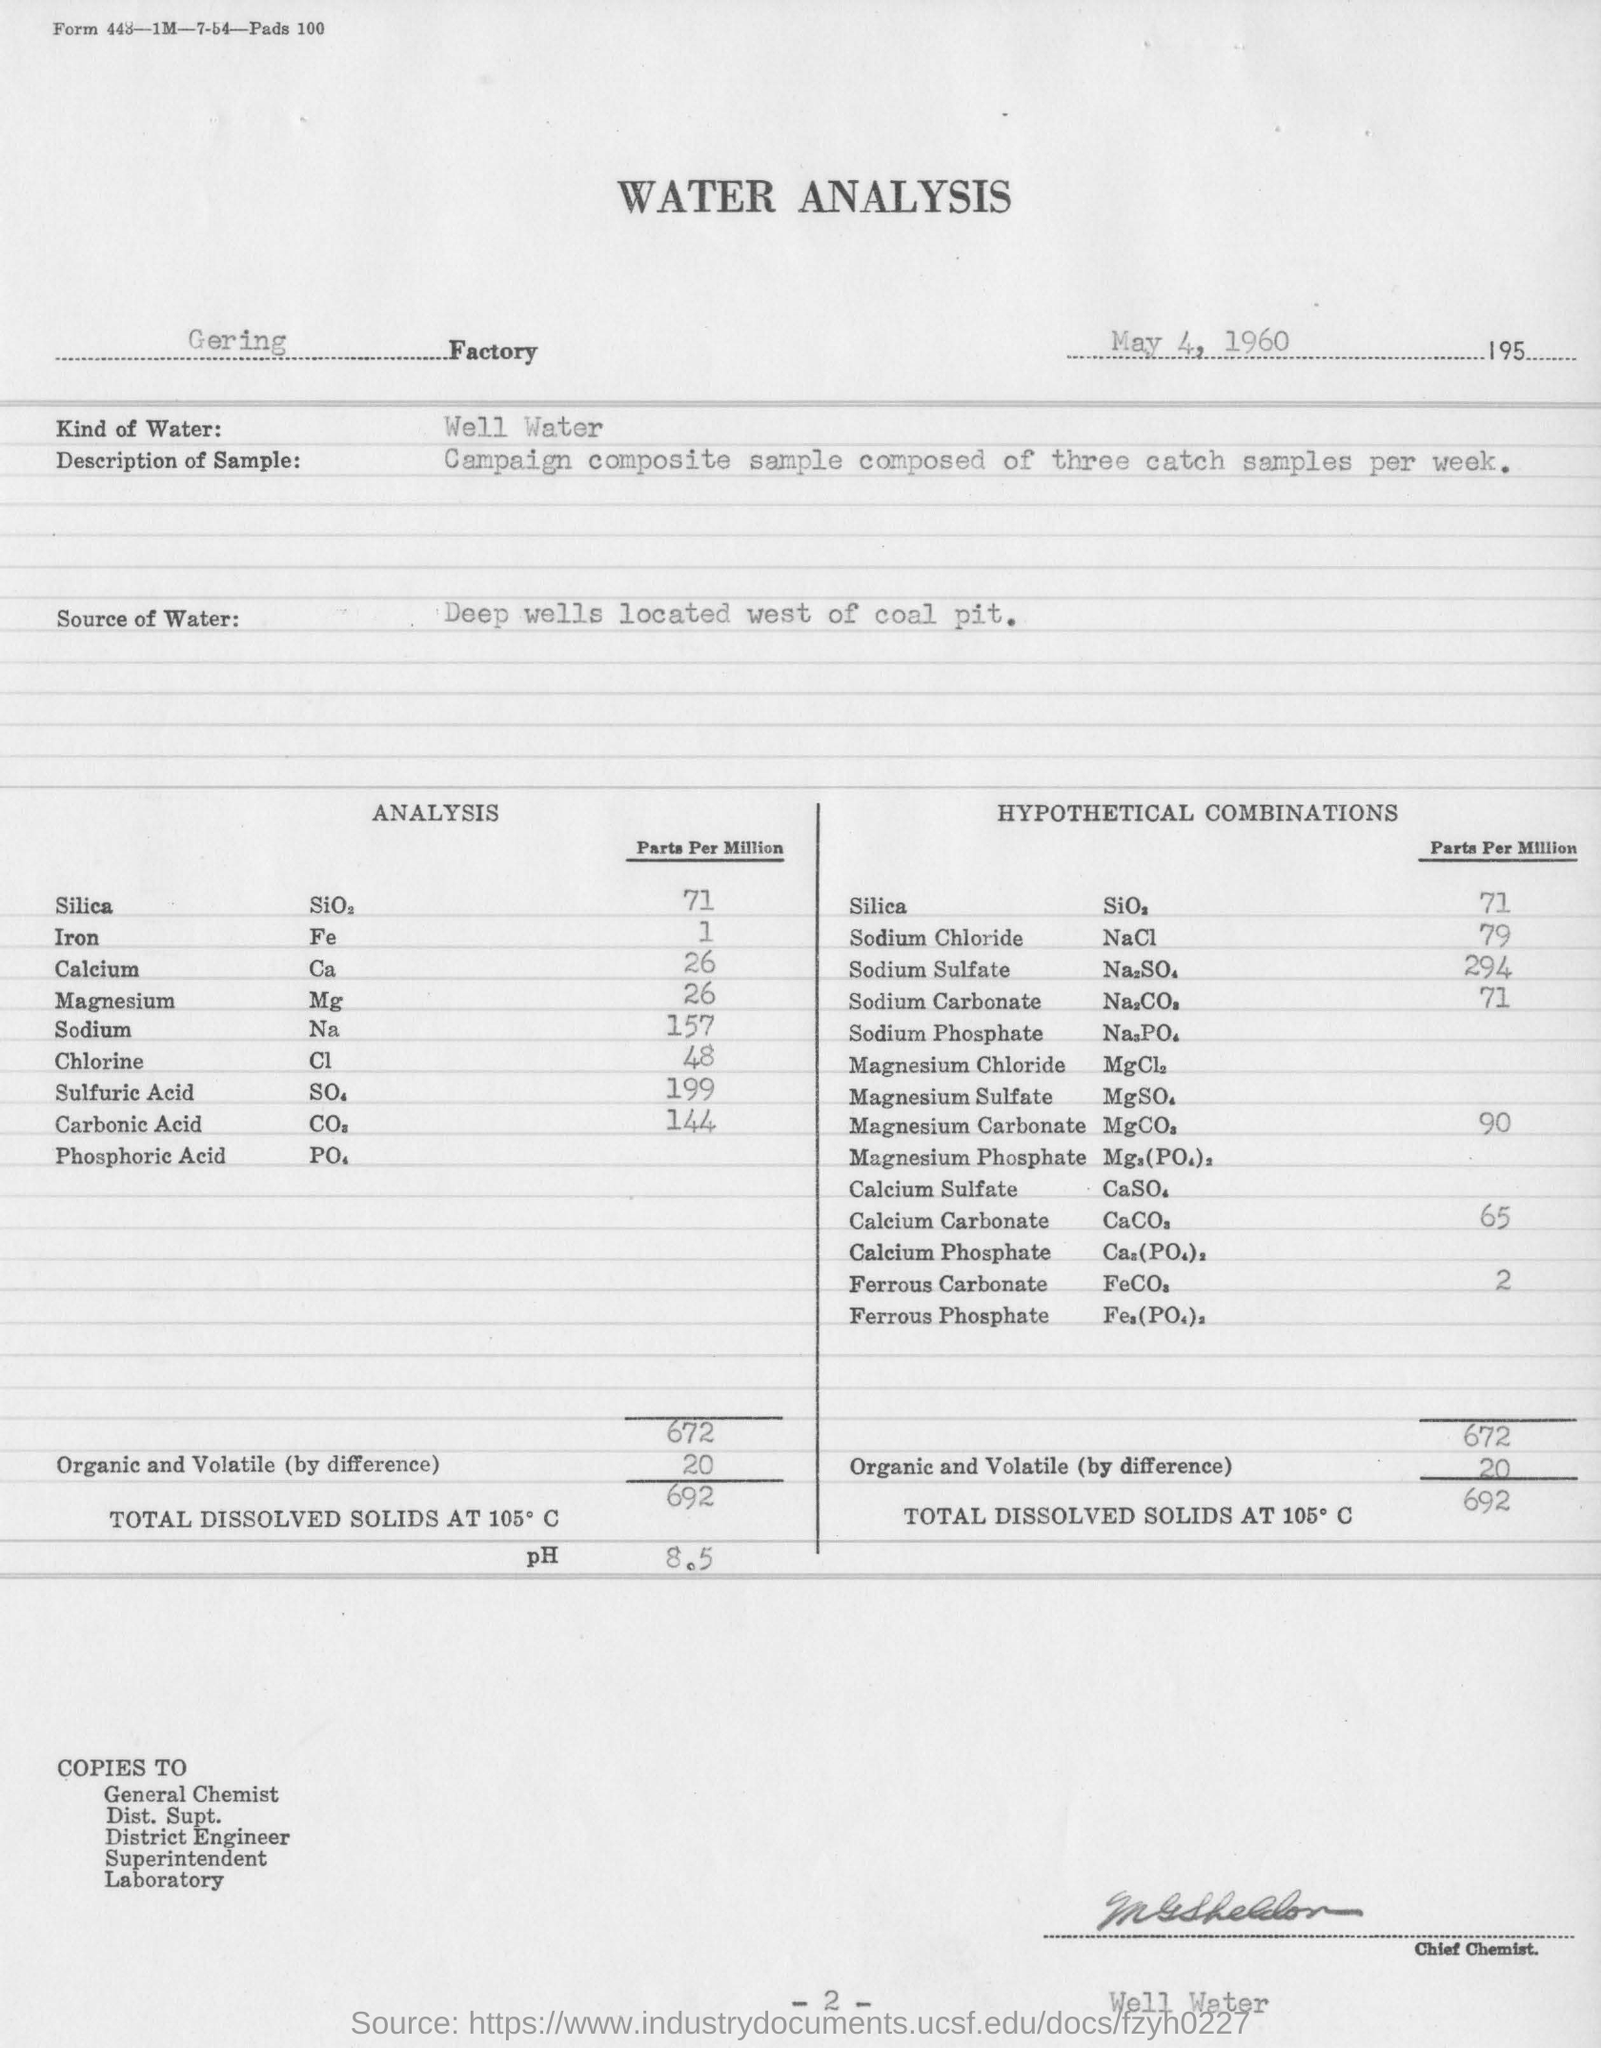Indicate a few pertinent items in this graphic. The date mentioned in this report is May 4, 1960. The source of water is obtained from deep wells located west of a coal pit. It is well water. 